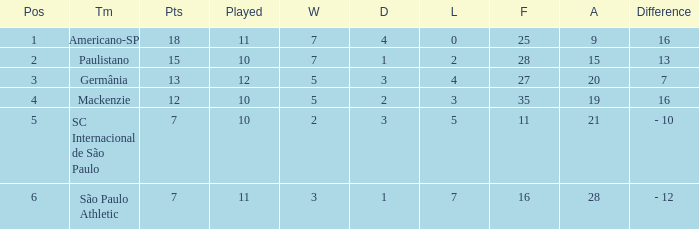Name the points for paulistano 15.0. Could you parse the entire table? {'header': ['Pos', 'Tm', 'Pts', 'Played', 'W', 'D', 'L', 'F', 'A', 'Difference'], 'rows': [['1', 'Americano-SP', '18', '11', '7', '4', '0', '25', '9', '16'], ['2', 'Paulistano', '15', '10', '7', '1', '2', '28', '15', '13'], ['3', 'Germânia', '13', '12', '5', '3', '4', '27', '20', '7'], ['4', 'Mackenzie', '12', '10', '5', '2', '3', '35', '19', '16'], ['5', 'SC Internacional de São Paulo', '7', '10', '2', '3', '5', '11', '21', '- 10'], ['6', 'São Paulo Athletic', '7', '11', '3', '1', '7', '16', '28', '- 12']]} 